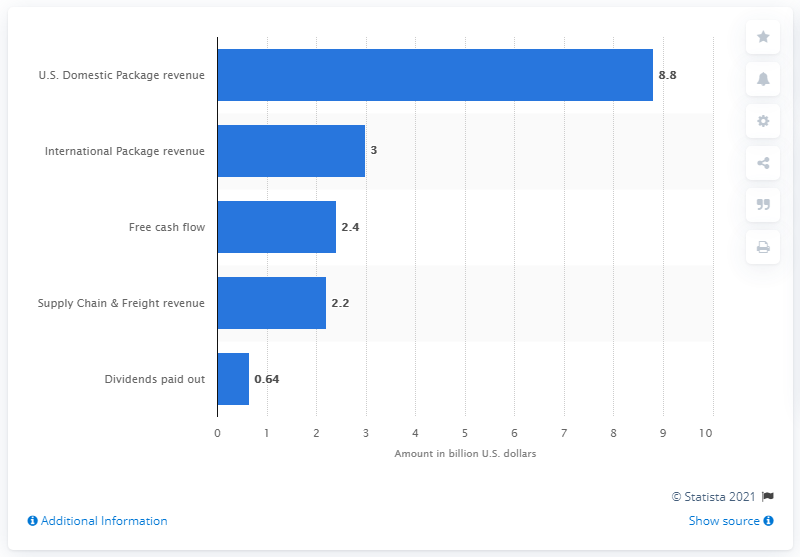Point out several critical features in this image. The free cash flow of United Parcel Service of America Inc. in the first quarter of 2015 was 2.4. 